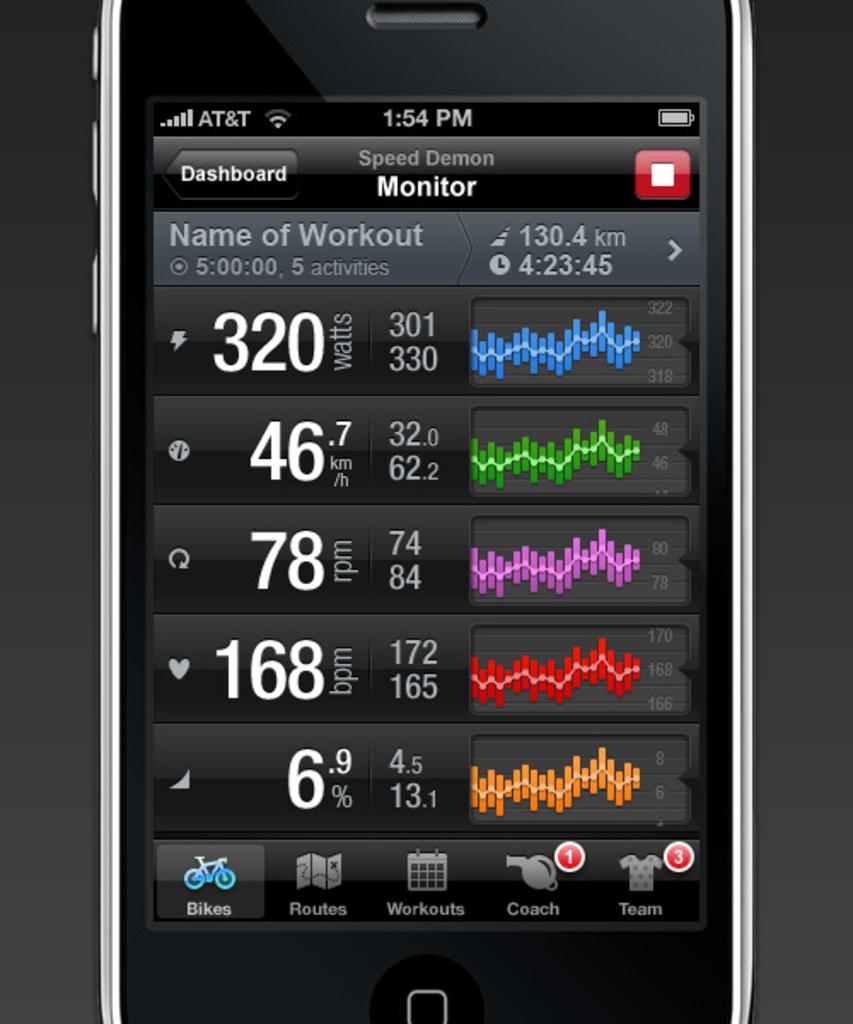Who is the service provider?
Provide a short and direct response. At&t. 